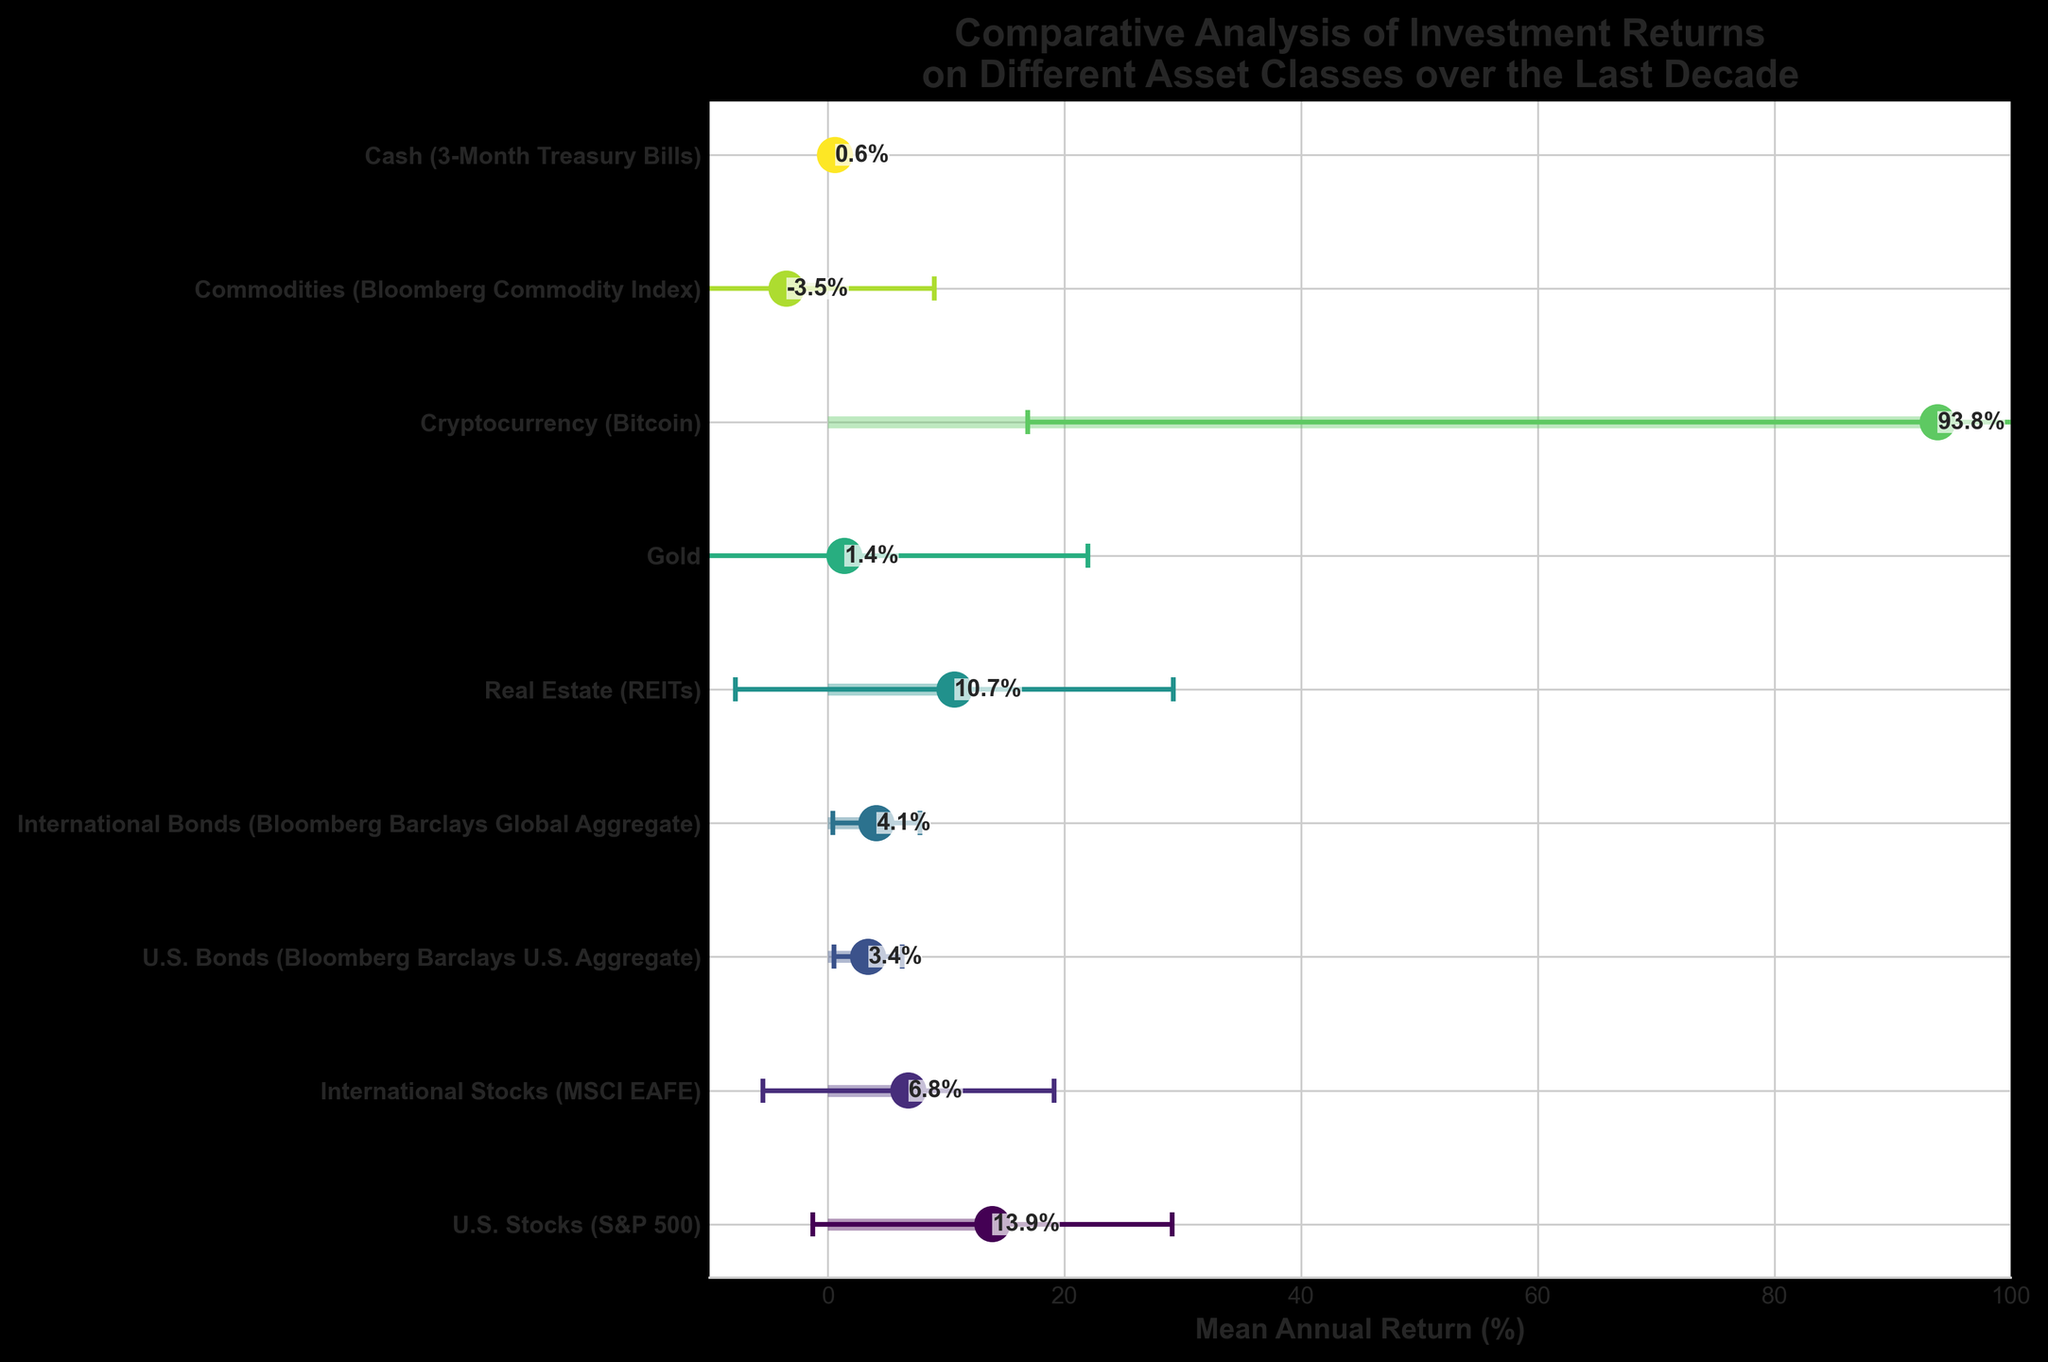What asset class has the highest mean annual return? The asset class with the highest mean annual return is the one with the highest dot position on the x-axis. From the figure, Cryptocurrency (Bitcoin) has the highest mean annual return, positioned at 93.8%.
Answer: Cryptocurrency (Bitcoin) Which asset class has the lowest mean annual return? The asset class with the lowest mean annual return has the lowest dot position on the x-axis. Cash (3-Month Treasury Bills) has the lowest mean annual return, positioned at 0.6%.
Answer: Cash (3-Month Treasury Bills) Which asset class has the highest standard deviation in returns? The asset class with the highest standard deviation will have the largest error bar. Cryptocurrency (Bitcoin) has the largest error bar, indicating a standard deviation of 76.9%.
Answer: Cryptocurrency (Bitcoin) What is the difference in mean annual return between U.S. Stocks (S&P 500) and International Stocks (MSCI EAFE)? Subtract the mean annual return of International Stocks (6.8%) from that of U.S. Stocks (13.9%). The difference is 13.9% - 6.8% = 7.1%.
Answer: 7.1% Which asset classes have negative mean annual returns? The asset classes with negative mean annual returns have dots positioned to the left of the y-axis. Commodities (Bloomberg Commodity Index) is the only class with a negative return of -3.5%.
Answer: Commodities (Bloomberg Commodity Index) What is the range of mean annual returns for Real Estate (REITs) considering its error bars? To find the range, add and subtract the standard deviation (18.5%) from the mean annual return (10.7%). The range is 10.7% ± 18.5%, which is -7.8% to 29.2%.
Answer: -7.8% to 29.2% How do the returns of U.S. Bonds compare to International Bonds? Compare the mean annual return positions on the x-axis. U.S. Bonds have a mean annual return of 3.4%, while International Bonds have 4.1%. International Bonds have a higher return by 0.7%.
Answer: International Bonds have higher returns by 0.7% Which asset classes have a higher mean annual return than Real Estate (REITs)? Identify asset classes with dots located further to the right than Real Estate's dot at 10.7%. Only U.S. Stocks (S&P 500) and Cryptocurrency (Bitcoin) have higher returns.
Answer: U.S. Stocks (S&P 500) and Cryptocurrency (Bitcoin) What is the mean annual return for Gold and how does it compare to the overall mean return of all asset classes? The mean return for Gold is 1.4%. Calculate the overall mean by averaging the returns of all asset classes. (13.9% + 6.8% + 3.4% + 4.1% + 10.7% + 1.4% + 93.8% + (-3.5%) + 0.6%) / 9 = 14.7%. Gold's return is less than the overall mean (1.4% < 14.7%).
Answer: Gold's mean return is lower than the overall mean Which asset class is the least volatile and what is its standard deviation? The asset class with the smallest error bar has the least volatility. Cash (3-Month Treasury Bills) has the smallest error bar, indicating a standard deviation of 0.1%.
Answer: Cash (3-Month Treasury Bills), 0.1% 